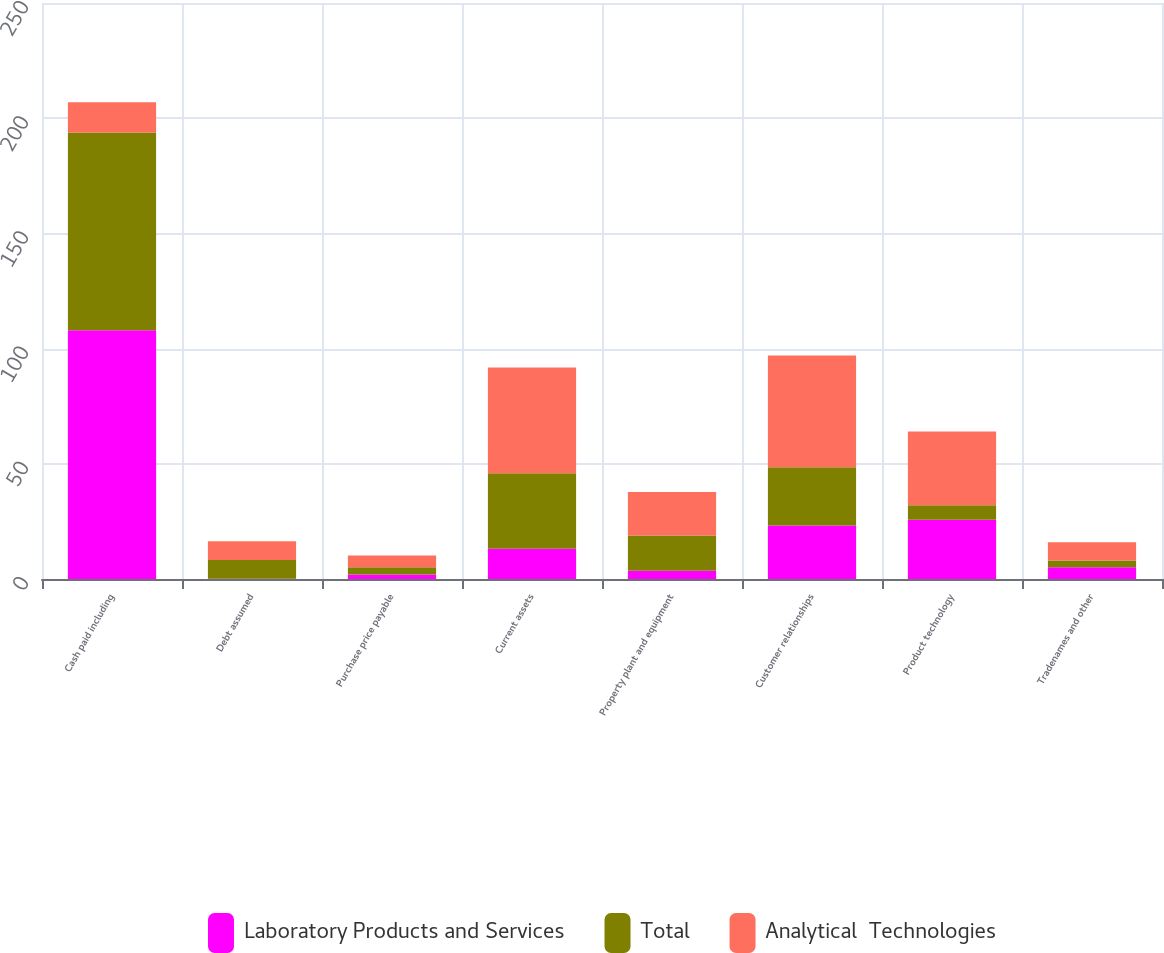Convert chart. <chart><loc_0><loc_0><loc_500><loc_500><stacked_bar_chart><ecel><fcel>Cash paid including<fcel>Debt assumed<fcel>Purchase price payable<fcel>Current assets<fcel>Property plant and equipment<fcel>Customer relationships<fcel>Product technology<fcel>Tradenames and other<nl><fcel>Laboratory Products and Services<fcel>108<fcel>0.1<fcel>2<fcel>13.1<fcel>3.6<fcel>23.2<fcel>25.7<fcel>5.1<nl><fcel>Total<fcel>85.8<fcel>8.1<fcel>3.1<fcel>32.8<fcel>15.3<fcel>25.3<fcel>6.3<fcel>2.9<nl><fcel>Analytical  Technologies<fcel>13.1<fcel>8.2<fcel>5.1<fcel>45.9<fcel>18.9<fcel>48.5<fcel>32<fcel>8<nl></chart> 